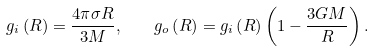<formula> <loc_0><loc_0><loc_500><loc_500>g _ { i } \left ( R \right ) = \frac { 4 \pi \sigma R } { 3 M } , \quad g _ { o } \left ( R \right ) = g _ { i } \left ( R \right ) \left ( 1 - \frac { 3 G M } { R } \right ) .</formula> 